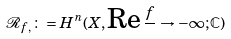Convert formula to latex. <formula><loc_0><loc_0><loc_500><loc_500>\mathcal { R } _ { f , } \colon = H ^ { n } ( X , \text {Re} \, \frac { f } { } \rightarrow - \infty ; \mathbb { C } )</formula> 